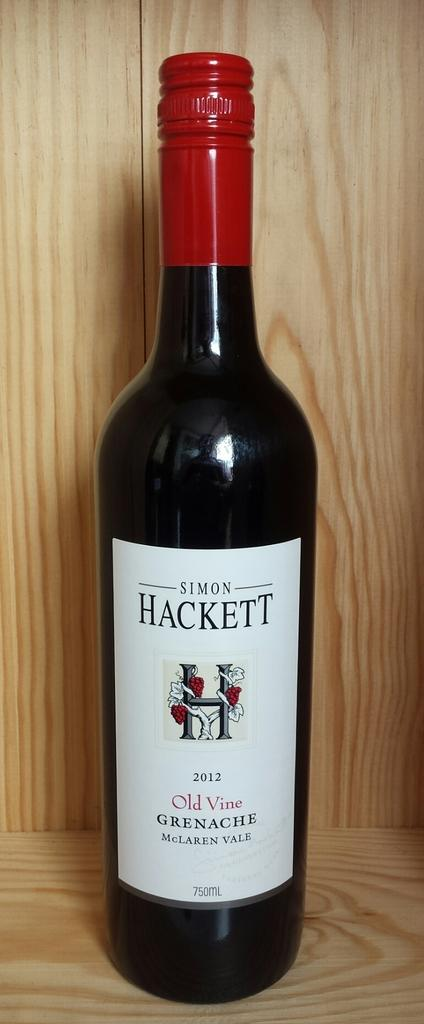<image>
Write a terse but informative summary of the picture. Bottle of Simon Hackett Old Vine Greenaches wine. 